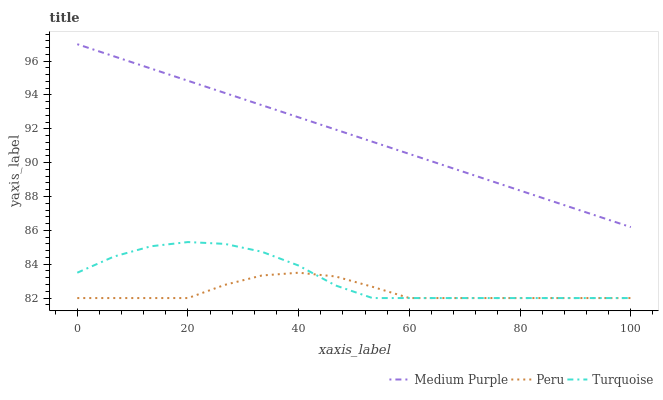Does Peru have the minimum area under the curve?
Answer yes or no. Yes. Does Medium Purple have the maximum area under the curve?
Answer yes or no. Yes. Does Turquoise have the minimum area under the curve?
Answer yes or no. No. Does Turquoise have the maximum area under the curve?
Answer yes or no. No. Is Medium Purple the smoothest?
Answer yes or no. Yes. Is Turquoise the roughest?
Answer yes or no. Yes. Is Peru the smoothest?
Answer yes or no. No. Is Peru the roughest?
Answer yes or no. No. Does Turquoise have the highest value?
Answer yes or no. No. Is Peru less than Medium Purple?
Answer yes or no. Yes. Is Medium Purple greater than Turquoise?
Answer yes or no. Yes. Does Peru intersect Medium Purple?
Answer yes or no. No. 